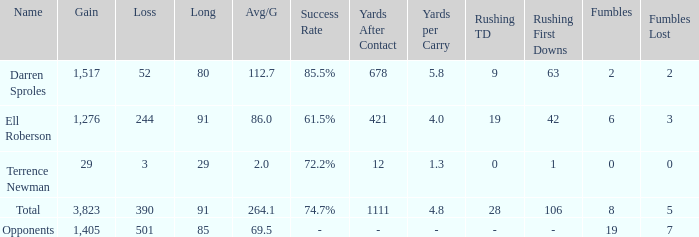When the Gain is 29, and the average per game is 2, and the player lost less than 390 yards, what's the sum of the Long yards? None. 